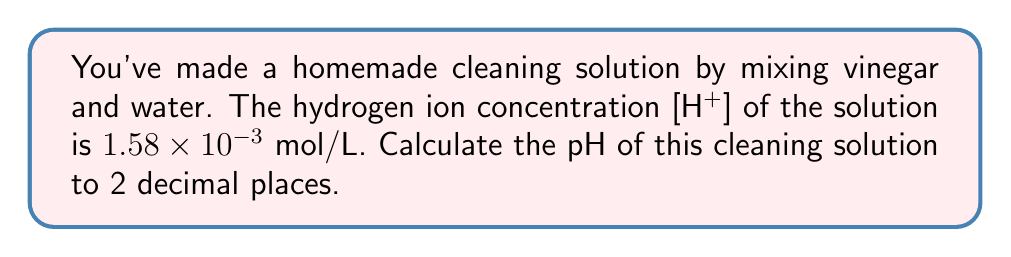Could you help me with this problem? Let's solve this step-by-step:

1) The pH of a solution is defined as the negative logarithm (base 10) of the hydrogen ion concentration [H+]:

   $$ pH = -\log_{10}[H^+] $$

2) We're given that [H+] = $1.58 \times 10^{-3}$ mol/L

3) Let's substitute this into our pH equation:

   $$ pH = -\log_{10}(1.58 \times 10^{-3}) $$

4) Using the logarithm property $\log(a \times 10^n) = \log(a) + n$, we can simplify:

   $$ pH = -(\log_{10}(1.58) + \log_{10}(10^{-3})) $$
   $$ pH = -(0.19866 + (-3)) $$

5) Simplifying further:

   $$ pH = -0.19866 + 3 = 2.80134 $$

6) Rounding to 2 decimal places:

   $$ pH \approx 2.80 $$

This pH indicates that your homemade cleaning solution is acidic, which is expected for a vinegar-based cleaner.
Answer: 2.80 